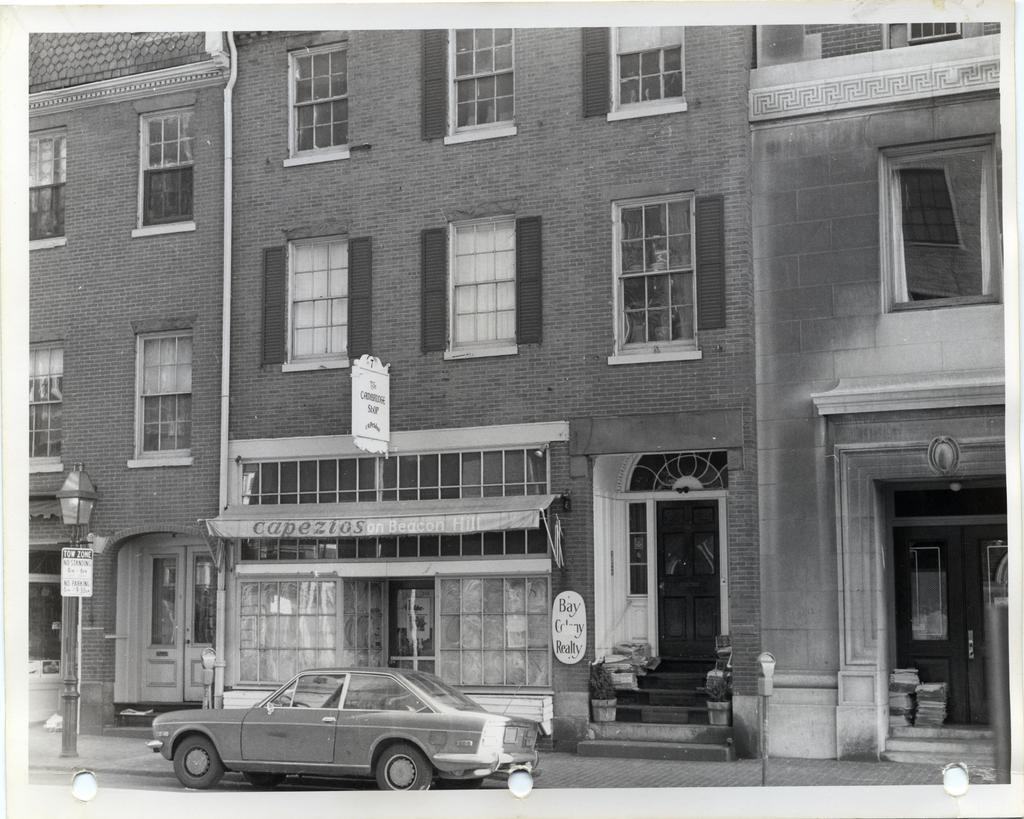How would you summarize this image in a sentence or two? In this image we can see a building, there are windows, doors, there is a car, a light pole, pipe, there are boards with text on them, there are some paper bundles in front of the doors, there are house plants, also the picture is taken in black and white mode. 